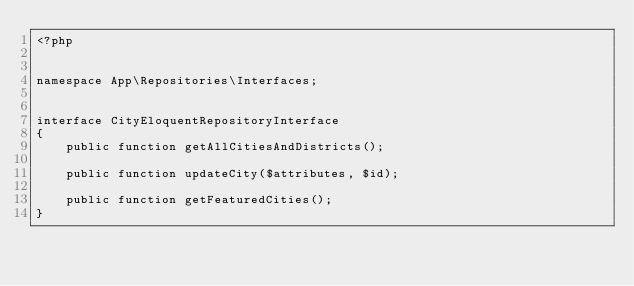Convert code to text. <code><loc_0><loc_0><loc_500><loc_500><_PHP_><?php


namespace App\Repositories\Interfaces;


interface CityEloquentRepositoryInterface
{
    public function getAllCitiesAndDistricts();

    public function updateCity($attributes, $id);

    public function getFeaturedCities();
}
</code> 